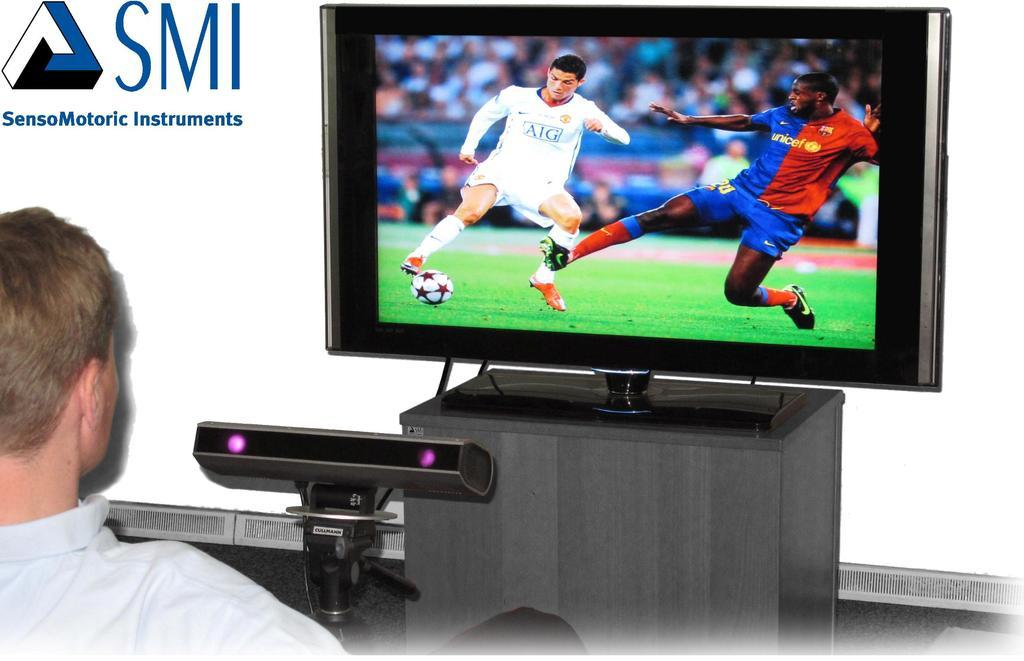<image>
Relay a brief, clear account of the picture shown. An ad for SensoMotoric Instruments shows a television. 